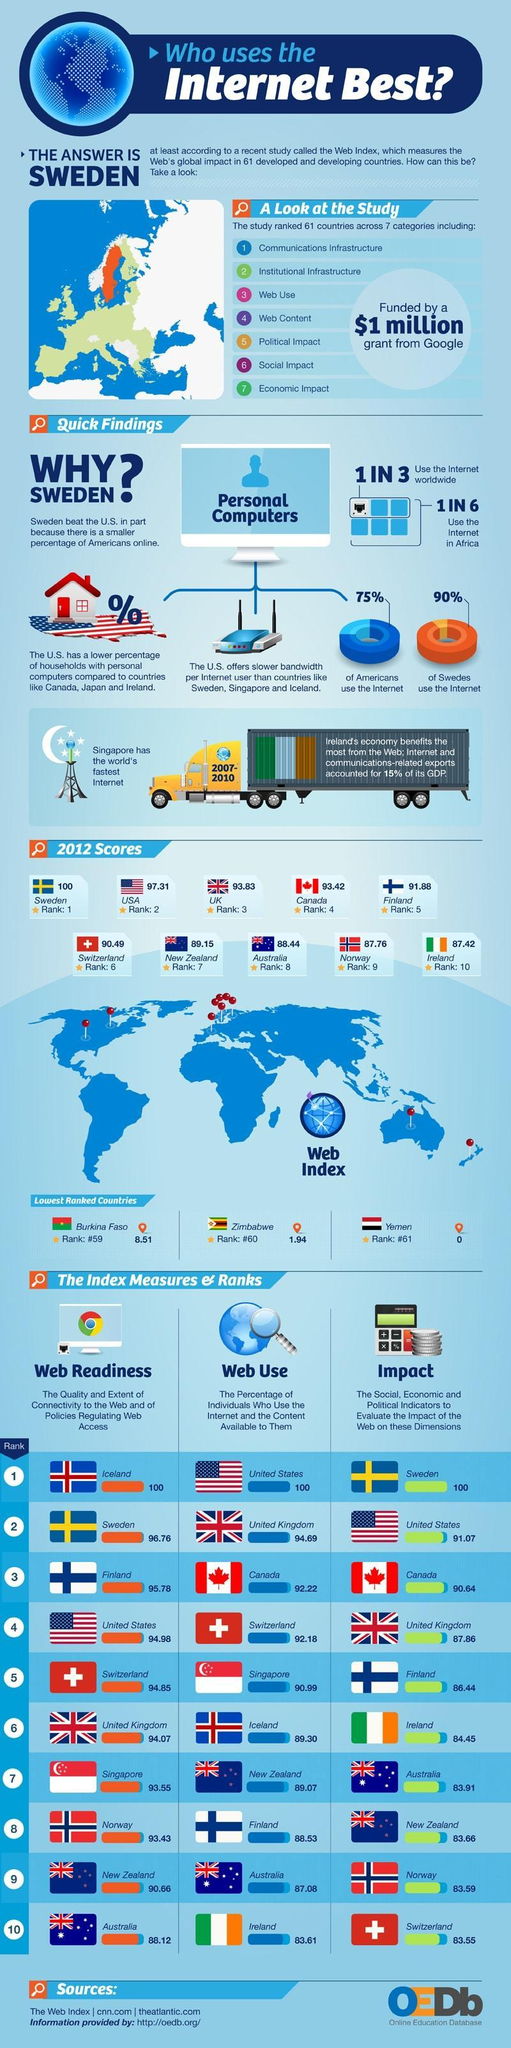Which country has the second highest web index score among the given countries in 2012?
Answer the question with a short phrase. USA What is the web index score of UK in 2012? 93.83 Which country has the highest web index score among the given countries in 2012? Sweden What is the web index score of Canada in 2012? 93.42 What percentage of the Australians use the internet & the contents available to them? 87.08 What percentage of Americans do not use the internet? 25% Which country has the lowest web index score among the given countries in 2012? Yemen What percentage of Swedes use the internet? 90% What is the web index score of Australia in 2012? 88.44 Which country has the second lowest web index score among the given countries in 2012? Zimbabwe 